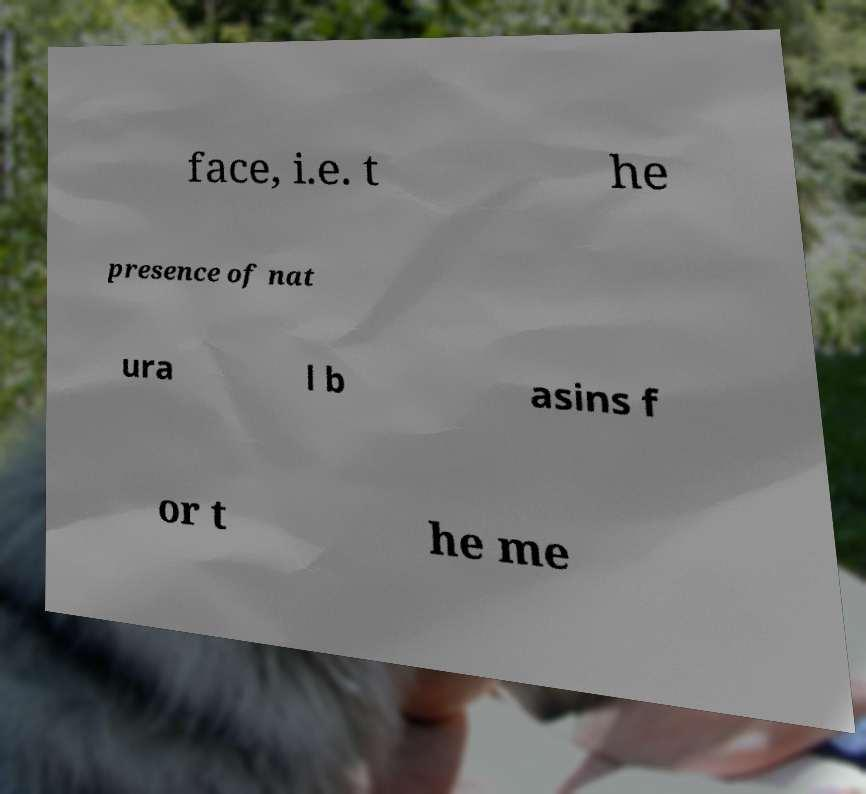Please identify and transcribe the text found in this image. face, i.e. t he presence of nat ura l b asins f or t he me 